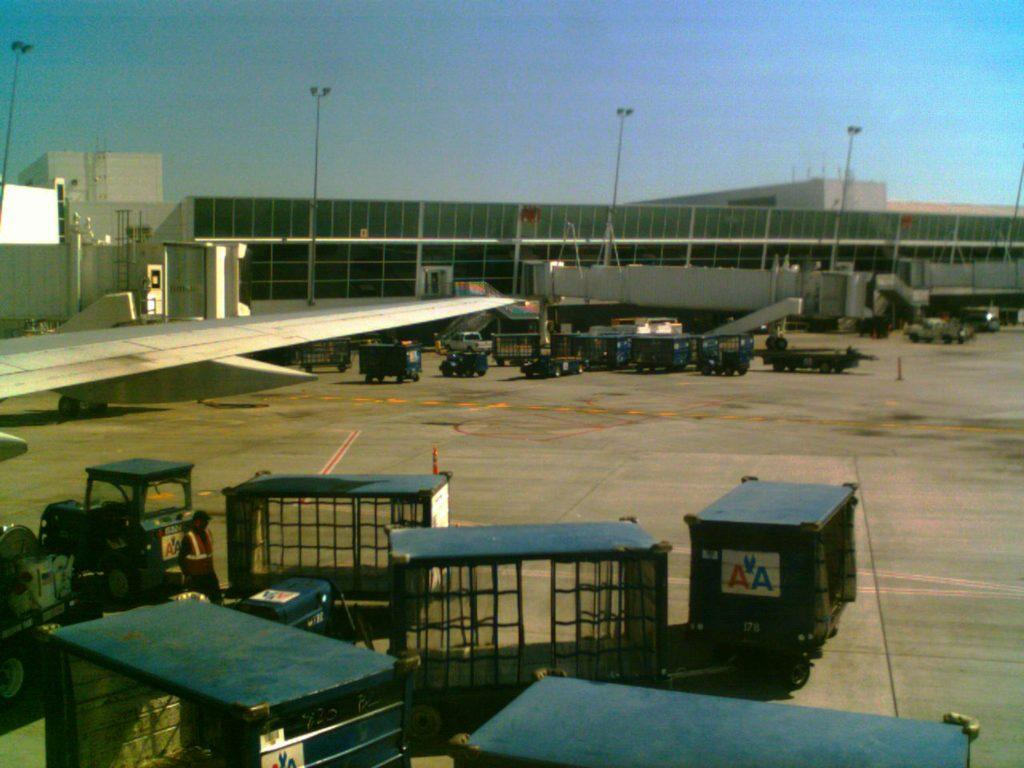<image>
Offer a succinct explanation of the picture presented. Luggage cards with the logo AA are being driven past an airplane at the airport. 